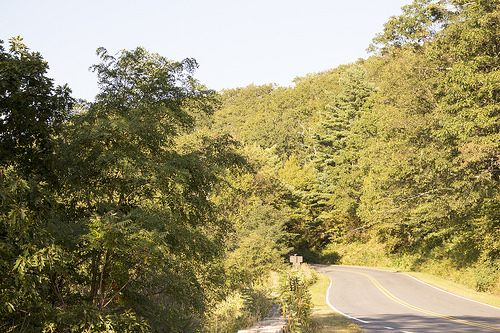<image>
Is there a road next to the trees? Yes. The road is positioned adjacent to the trees, located nearby in the same general area. 